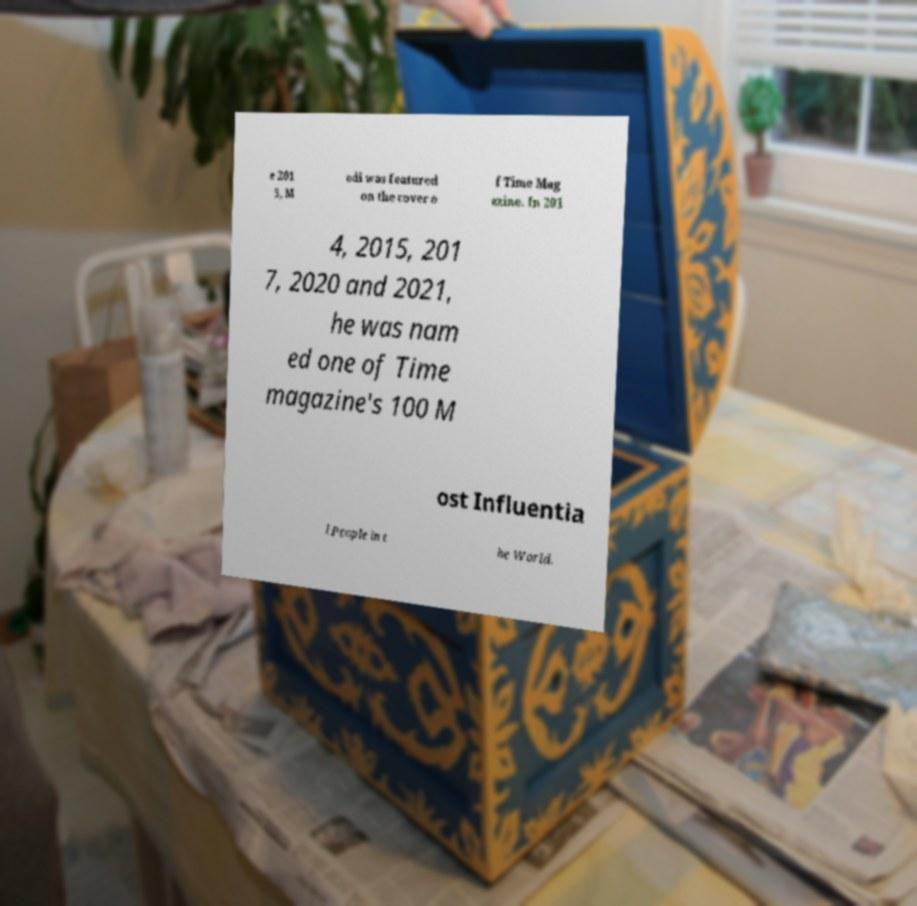For documentation purposes, I need the text within this image transcribed. Could you provide that? e 201 5, M odi was featured on the cover o f Time Mag azine. In 201 4, 2015, 201 7, 2020 and 2021, he was nam ed one of Time magazine's 100 M ost Influentia l People in t he World. 